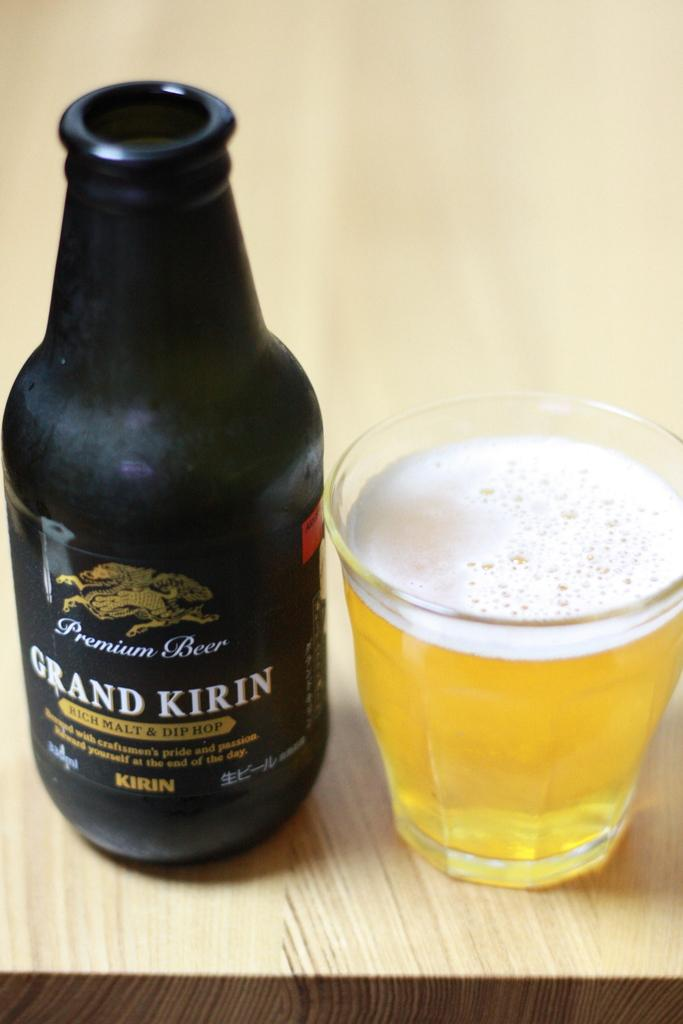<image>
Offer a succinct explanation of the picture presented. A full glass next to a bottle of Grand Kirin 